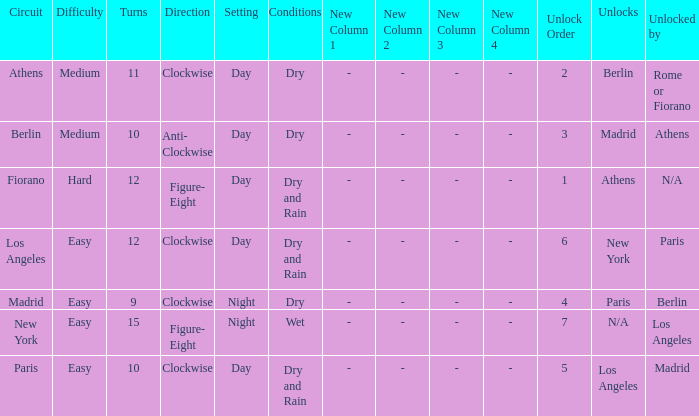What is the lowest unlock order for the athens circuit? 2.0. 